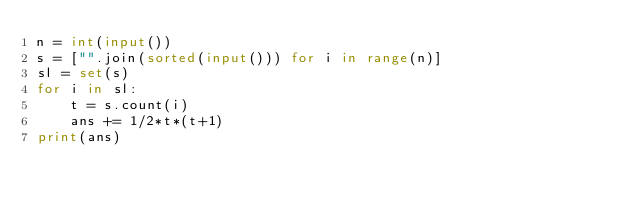Convert code to text. <code><loc_0><loc_0><loc_500><loc_500><_Python_>n = int(input())
s = ["".join(sorted(input())) for i in range(n)]
sl = set(s)
for i in sl:
    t = s.count(i)
    ans += 1/2*t*(t+1)
print(ans)
</code> 